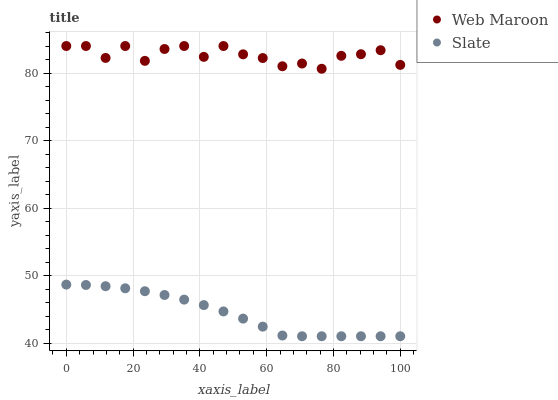Does Slate have the minimum area under the curve?
Answer yes or no. Yes. Does Web Maroon have the maximum area under the curve?
Answer yes or no. Yes. Does Web Maroon have the minimum area under the curve?
Answer yes or no. No. Is Slate the smoothest?
Answer yes or no. Yes. Is Web Maroon the roughest?
Answer yes or no. Yes. Is Web Maroon the smoothest?
Answer yes or no. No. Does Slate have the lowest value?
Answer yes or no. Yes. Does Web Maroon have the lowest value?
Answer yes or no. No. Does Web Maroon have the highest value?
Answer yes or no. Yes. Is Slate less than Web Maroon?
Answer yes or no. Yes. Is Web Maroon greater than Slate?
Answer yes or no. Yes. Does Slate intersect Web Maroon?
Answer yes or no. No. 